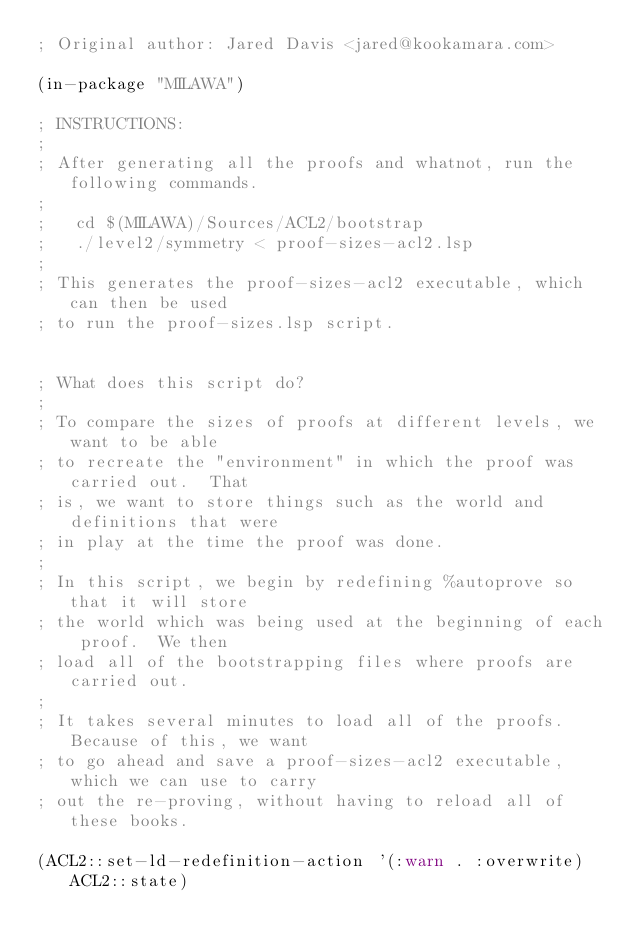Convert code to text. <code><loc_0><loc_0><loc_500><loc_500><_Lisp_>; Original author: Jared Davis <jared@kookamara.com>

(in-package "MILAWA")

; INSTRUCTIONS:
;
; After generating all the proofs and whatnot, run the following commands.
;
;   cd $(MILAWA)/Sources/ACL2/bootstrap
;   ./level2/symmetry < proof-sizes-acl2.lsp
;
; This generates the proof-sizes-acl2 executable, which can then be used
; to run the proof-sizes.lsp script.


; What does this script do?
;
; To compare the sizes of proofs at different levels, we want to be able
; to recreate the "environment" in which the proof was carried out.  That
; is, we want to store things such as the world and definitions that were
; in play at the time the proof was done.
;
; In this script, we begin by redefining %autoprove so that it will store
; the world which was being used at the beginning of each proof.  We then
; load all of the bootstrapping files where proofs are carried out.
;
; It takes several minutes to load all of the proofs.  Because of this, we want
; to go ahead and save a proof-sizes-acl2 executable, which we can use to carry
; out the re-proving, without having to reload all of these books.

(ACL2::set-ld-redefinition-action '(:warn . :overwrite) ACL2::state)
</code> 